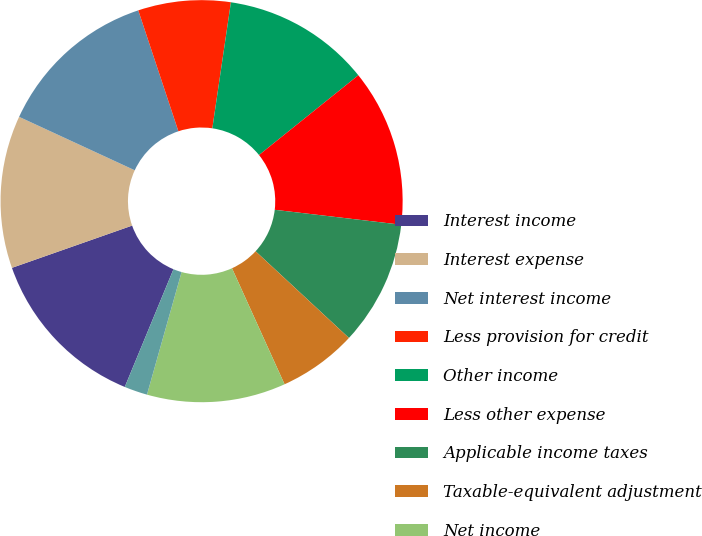<chart> <loc_0><loc_0><loc_500><loc_500><pie_chart><fcel>Interest income<fcel>Interest expense<fcel>Net interest income<fcel>Less provision for credit<fcel>Other income<fcel>Less other expense<fcel>Applicable income taxes<fcel>Taxable-equivalent adjustment<fcel>Net income<fcel>Basic earnings<nl><fcel>13.38%<fcel>12.27%<fcel>13.01%<fcel>7.43%<fcel>11.9%<fcel>12.64%<fcel>10.04%<fcel>6.32%<fcel>11.15%<fcel>1.86%<nl></chart> 